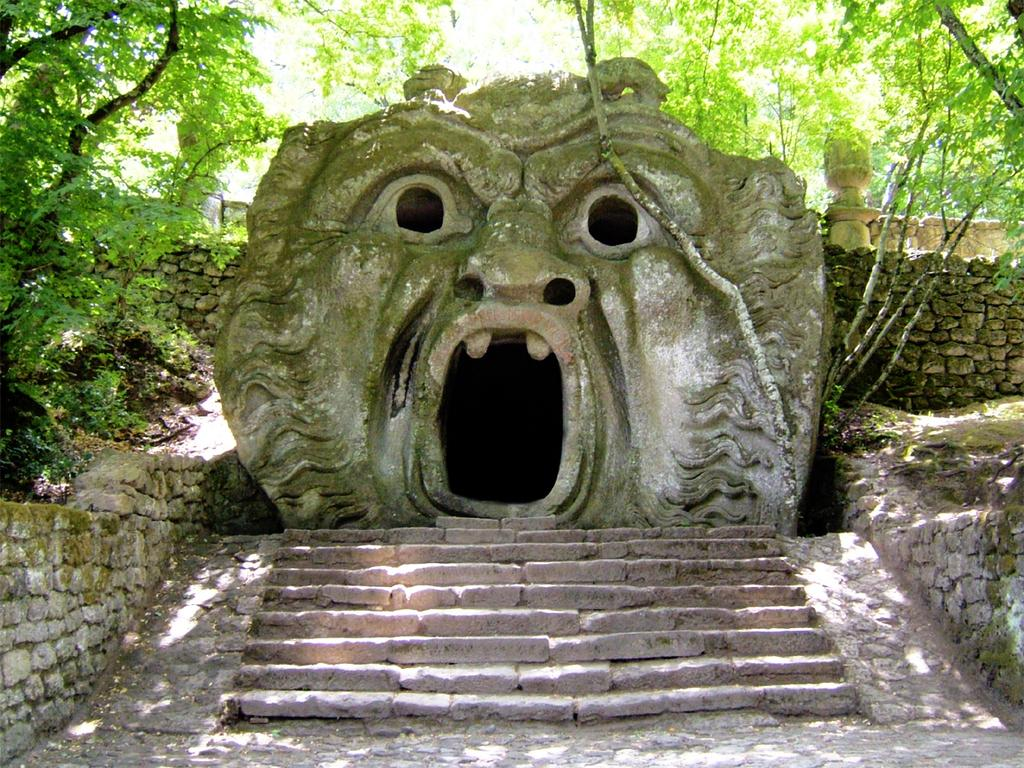What type of structure is present in the image? There are stairs in the image. What artistic element can be seen in the image? There is a sculpture in the image. What architectural feature is visible in the image? There is a wall in the image. What type of natural scenery is visible in the background of the image? There are trees visible in the background of the image. What type of plastic material is used to create the goose in the image? There is no goose present in the image; it features stairs, a sculpture, a wall, and trees in the background. Can you tell me the credit limit of the person in the image? There is no person present in the image, and therefore no credit limit can be determined. 